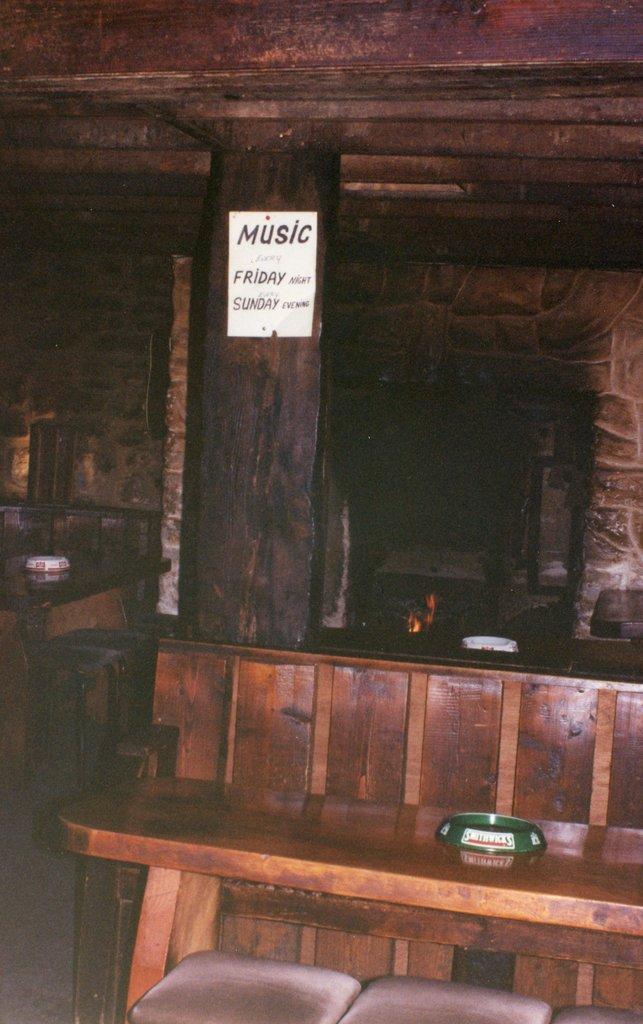Describe this image in one or two sentences. In this image there is a wooden bench in the middle. In front of the bench there are two stools. In the background there is a pillar to which there is a poster. On the left side there is a table on which there is a bowl. 